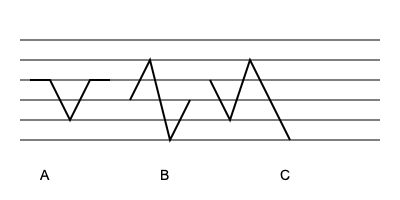Identify the picking pattern that most closely resembles an arpeggio technique commonly used in indie folk music. Which pattern (A, B, or C) would be most suitable for creating a dreamy, atmospheric sound in your songwriting? To answer this question, let's analyze each picking pattern:

1. Pattern A: This shows a simple up-and-down strumming pattern. It's a basic technique used in many genres but doesn't create the flowing, dreamy sound typically associated with indie folk.

2. Pattern B: This pattern alternates between high and low notes, creating a see-saw effect. While more interesting than pattern A, it still doesn't capture the essence of an arpeggio.

3. Pattern C: This pattern shows a more complex movement across the strings, starting on a middle string, moving to a higher string, then to a lower string, and finally sweeping across all strings. This closely resembles an arpeggio technique.

Arpeggios are a common technique in indie folk music, where individual notes of a chord are played in sequence rather than simultaneously. They create a flowing, ethereal sound that's often described as dreamy or atmospheric.

Pattern C, with its sweeping motion across the strings, would allow you to play the notes of a chord individually in a flowing manner. This technique is frequently used by indie folk artists like Bon Iver, Fleet Foxes, or Iron & Wine to create lush, atmospheric soundscapes.

By incorporating this arpeggio-like picking pattern into your guitar playing, you can add depth and texture to your indie singer-songwriter compositions, helping to create the dreamy, atmospheric sound characteristic of the genre.
Answer: C 